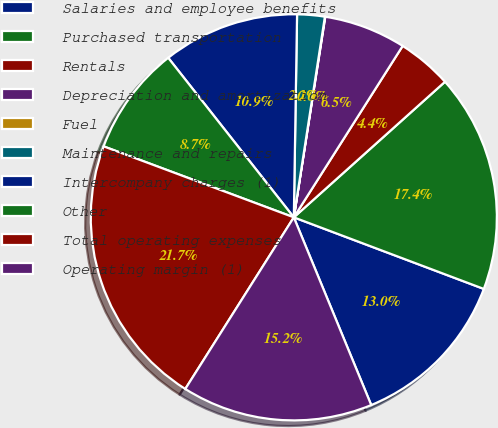Convert chart. <chart><loc_0><loc_0><loc_500><loc_500><pie_chart><fcel>Salaries and employee benefits<fcel>Purchased transportation<fcel>Rentals<fcel>Depreciation and amortization<fcel>Fuel<fcel>Maintenance and repairs<fcel>Intercompany charges (1)<fcel>Other<fcel>Total operating expenses<fcel>Operating margin (1)<nl><fcel>13.04%<fcel>17.37%<fcel>4.36%<fcel>6.53%<fcel>0.03%<fcel>2.19%<fcel>10.87%<fcel>8.7%<fcel>21.71%<fcel>15.2%<nl></chart> 